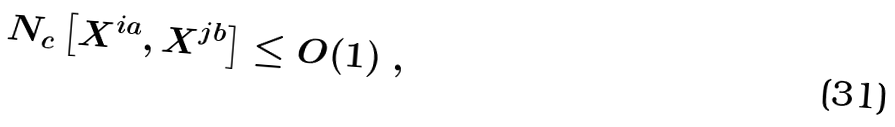Convert formula to latex. <formula><loc_0><loc_0><loc_500><loc_500>N _ { c } \left [ X ^ { i a } , X ^ { j b } \right ] \leq O ( 1 ) \ ,</formula> 